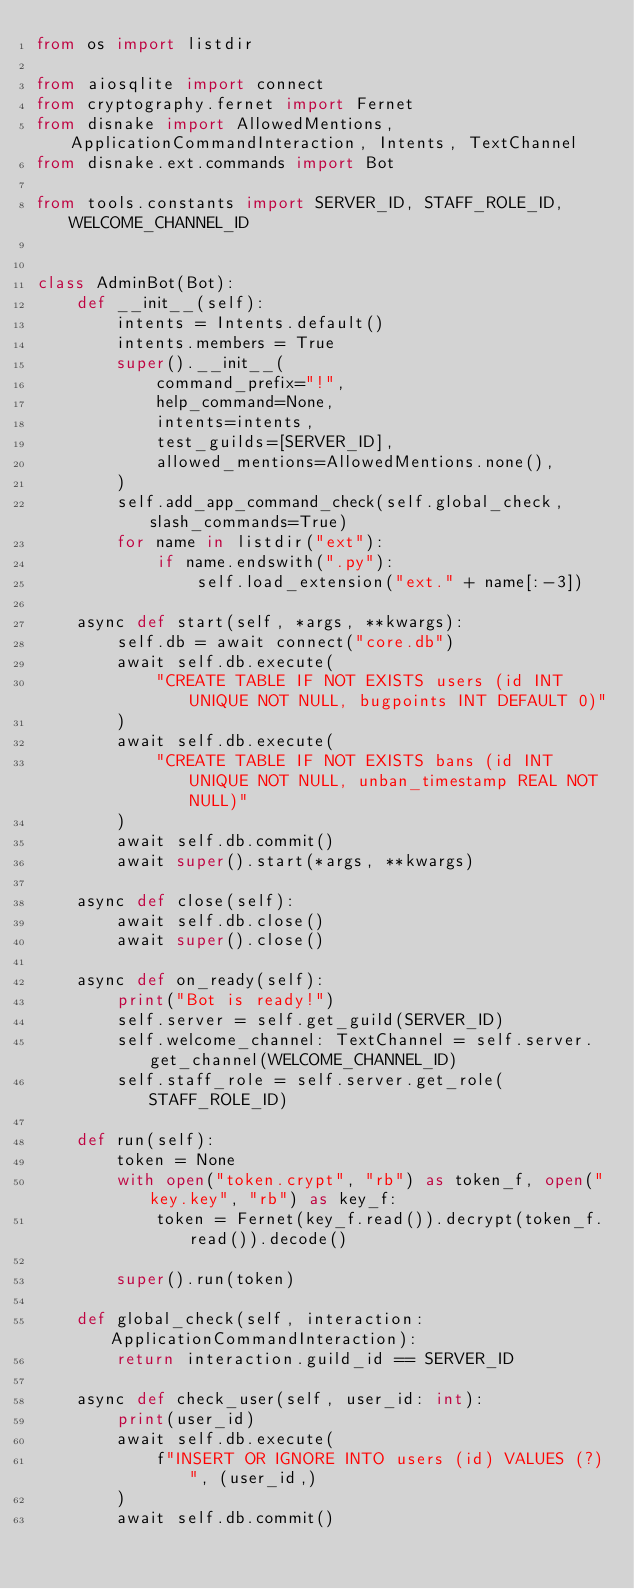<code> <loc_0><loc_0><loc_500><loc_500><_Python_>from os import listdir

from aiosqlite import connect
from cryptography.fernet import Fernet
from disnake import AllowedMentions, ApplicationCommandInteraction, Intents, TextChannel
from disnake.ext.commands import Bot

from tools.constants import SERVER_ID, STAFF_ROLE_ID, WELCOME_CHANNEL_ID


class AdminBot(Bot):
    def __init__(self):
        intents = Intents.default()
        intents.members = True
        super().__init__(
            command_prefix="!",
            help_command=None,
            intents=intents,
            test_guilds=[SERVER_ID],
            allowed_mentions=AllowedMentions.none(),
        )
        self.add_app_command_check(self.global_check, slash_commands=True)
        for name in listdir("ext"):
            if name.endswith(".py"):
                self.load_extension("ext." + name[:-3])

    async def start(self, *args, **kwargs):
        self.db = await connect("core.db")
        await self.db.execute(
            "CREATE TABLE IF NOT EXISTS users (id INT UNIQUE NOT NULL, bugpoints INT DEFAULT 0)"
        )
        await self.db.execute(
            "CREATE TABLE IF NOT EXISTS bans (id INT UNIQUE NOT NULL, unban_timestamp REAL NOT NULL)"
        )
        await self.db.commit()
        await super().start(*args, **kwargs)

    async def close(self):
        await self.db.close()
        await super().close()

    async def on_ready(self):
        print("Bot is ready!")
        self.server = self.get_guild(SERVER_ID)
        self.welcome_channel: TextChannel = self.server.get_channel(WELCOME_CHANNEL_ID)
        self.staff_role = self.server.get_role(STAFF_ROLE_ID)

    def run(self):
        token = None
        with open("token.crypt", "rb") as token_f, open("key.key", "rb") as key_f:
            token = Fernet(key_f.read()).decrypt(token_f.read()).decode()

        super().run(token)

    def global_check(self, interaction: ApplicationCommandInteraction):
        return interaction.guild_id == SERVER_ID

    async def check_user(self, user_id: int):
        print(user_id)
        await self.db.execute(
            f"INSERT OR IGNORE INTO users (id) VALUES (?)", (user_id,)
        )
        await self.db.commit()
</code> 